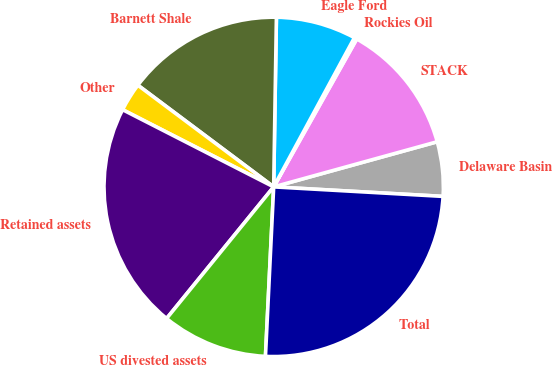Convert chart to OTSL. <chart><loc_0><loc_0><loc_500><loc_500><pie_chart><fcel>Delaware Basin<fcel>STACK<fcel>Rockies Oil<fcel>Eagle Ford<fcel>Barnett Shale<fcel>Other<fcel>Retained assets<fcel>US divested assets<fcel>Total<nl><fcel>5.18%<fcel>12.57%<fcel>0.25%<fcel>7.64%<fcel>15.03%<fcel>2.71%<fcel>21.65%<fcel>10.1%<fcel>24.88%<nl></chart> 